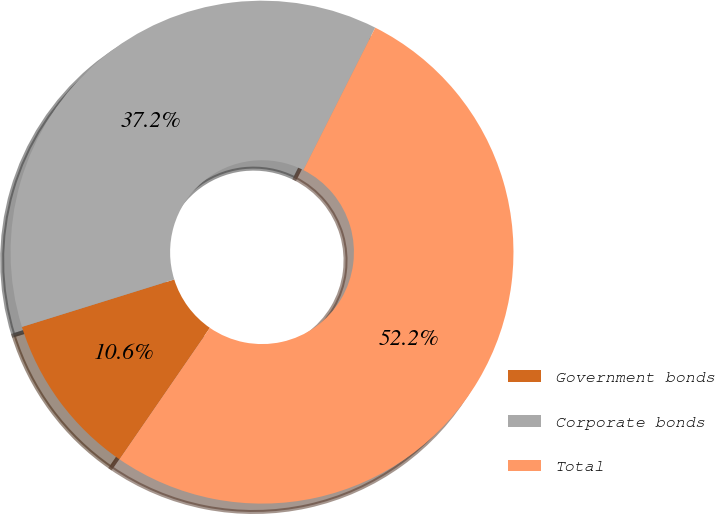<chart> <loc_0><loc_0><loc_500><loc_500><pie_chart><fcel>Government bonds<fcel>Corporate bonds<fcel>Total<nl><fcel>10.6%<fcel>37.24%<fcel>52.16%<nl></chart> 